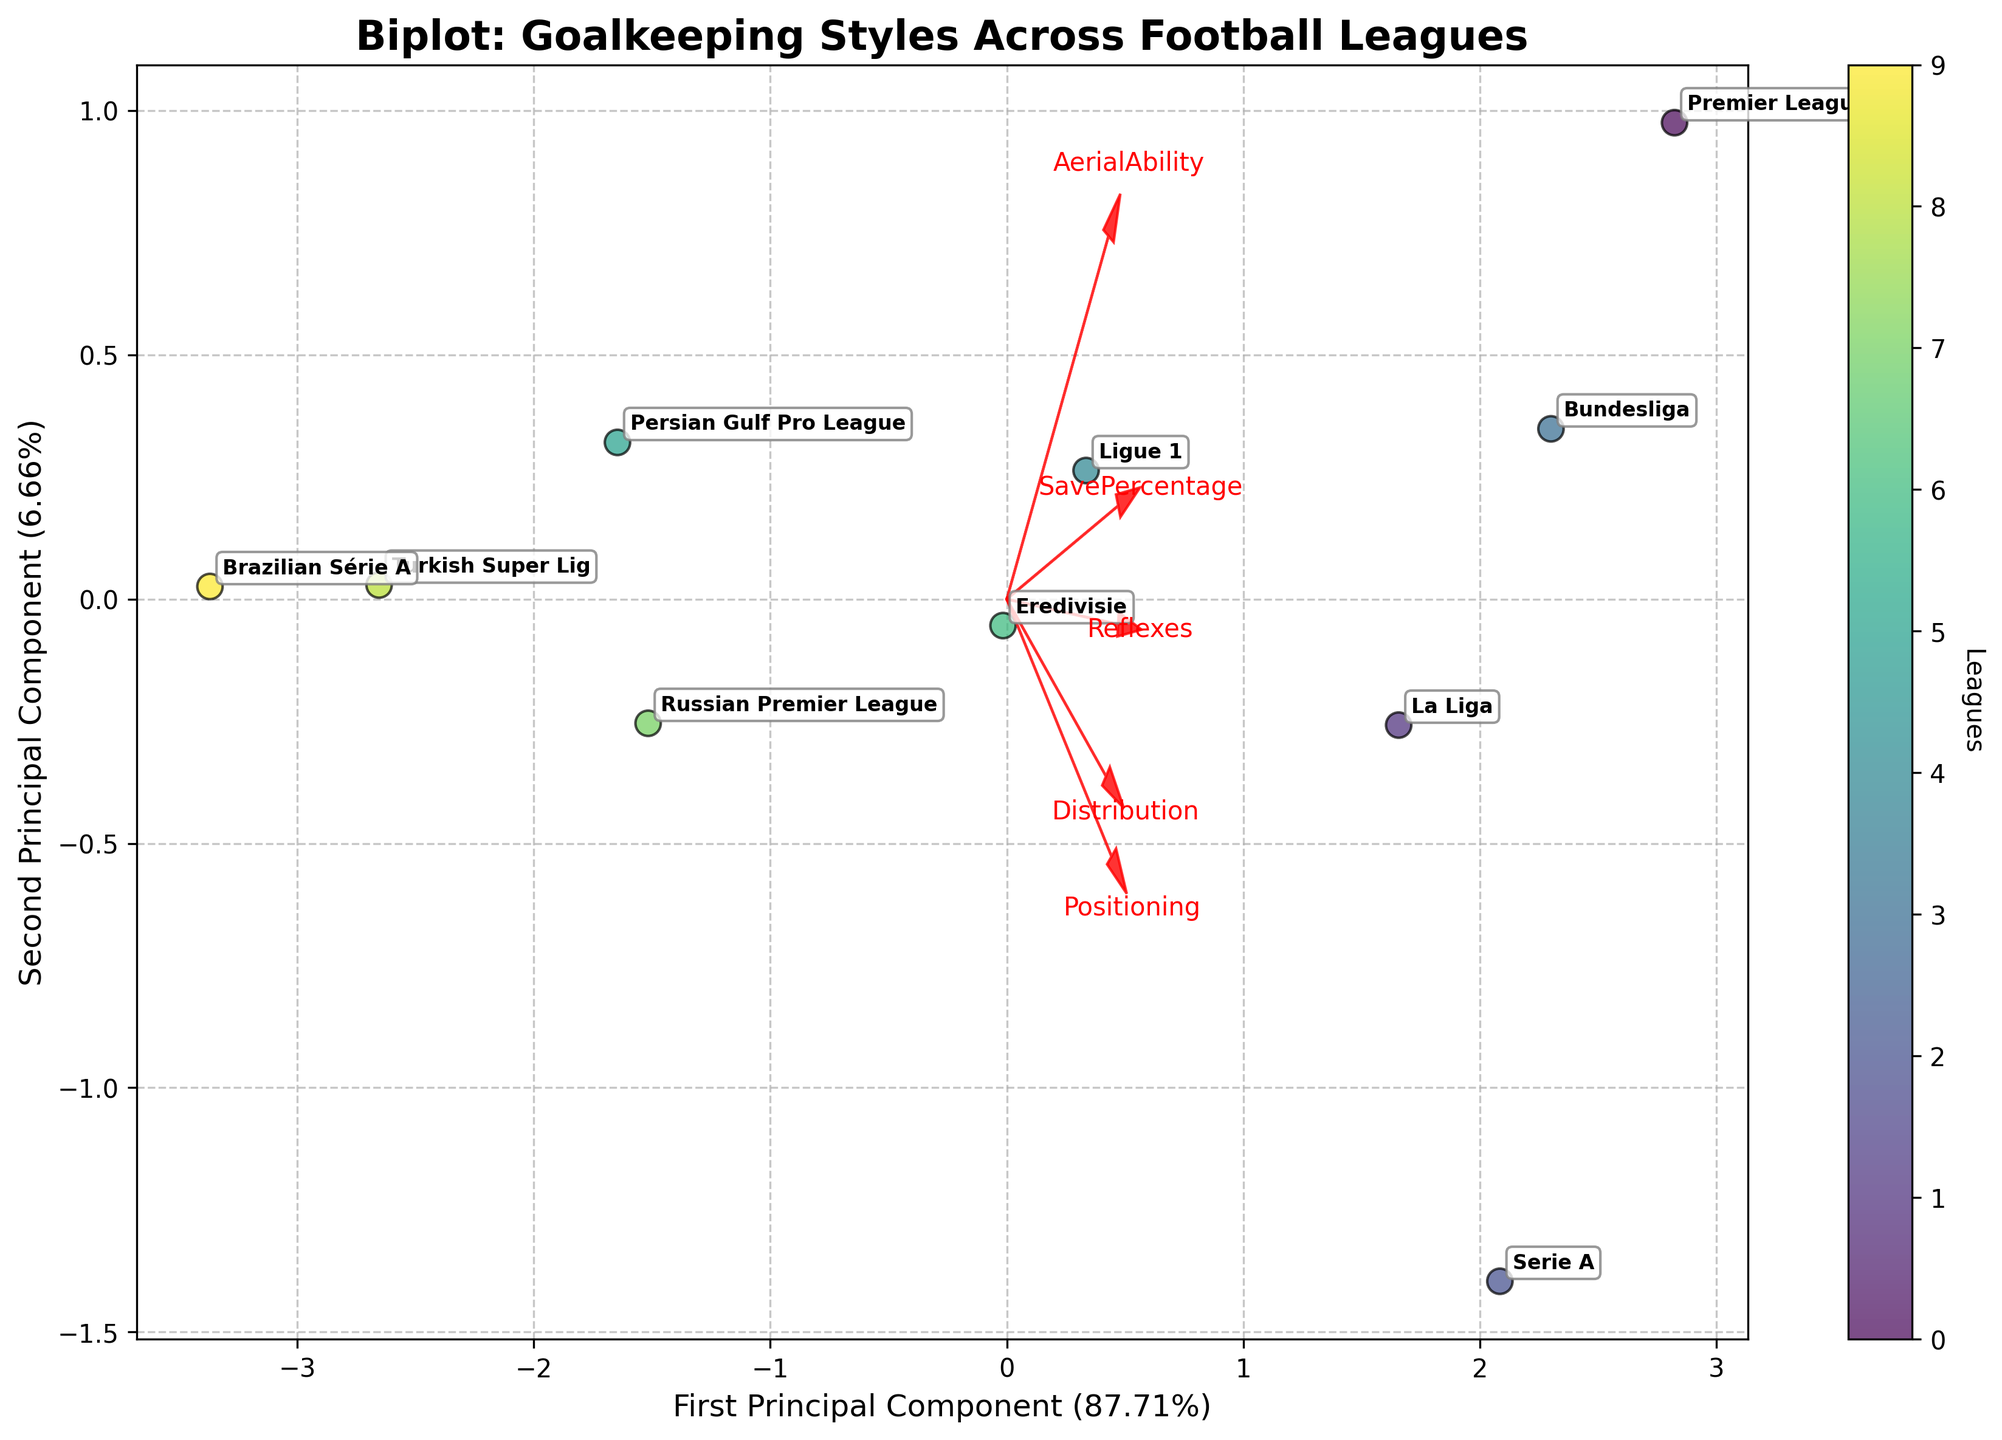What is the title of the plot? The title is typically located at the top of the plot and is often displayed in a larger or bold font. Here, the title reads "Biplot: Goalkeeping Styles Across Football Leagues".
Answer: Biplot: Goalkeeping Styles Across Football Leagues Which league has the highest Save Percentage? Review the distribution of the data points and their corresponding labels. The Premier League is indicated to have the highest Save Percentage value, as seen in the plot.
Answer: Premier League Which league has the lowest Positioning score? By examining the arrows representing the features, locate the positioning vector. Look for the data point furthest along the negative direction of this arrow, which, in this plot, is the Brazilian Série A.
Answer: Brazilian Série A How much of the variance is explained by the first Principal Component? The percentage of variance explained by each component is often labeled on the axis of the plot. Here, the x-axis label shows "First Principal Component (XX%)". We extract the percentage from this label.
Answer: (check axis label for the exact %) Which two leagues cluster closely together in the biplot? Identify clusters by looking for data points that are very close to each other. In this plot, the Bundesliga and La Liga can be seen clustering closely.
Answer: Bundesliga and La Liga How does the Persian Gulf Pro League's Distribution compare to the Premier League's Distribution? Follow the arrow representing the Distribution feature. The Premier League data point is further along in the positive direction relative to the Persian Gulf Pro League data point, indicating it has higher distribution.
Answer: Premier League has higher Distribution Which league shows a prominent balance of both Reflexes and Positioning? Locate the vectors for Reflexes and Positioning. The Serie A league lies well-balanced along these two vectors compared to others, suggesting balanced skills in both aspects.
Answer: Serie A What percentage of the variance is explained by the second Principal Component? This information is found in the y-axis label, where it states "Second Principal Component (YY%)". Extract the percentage from this label.
Answer: (check axis label for the exact %) Which feature appears to have the least variation across leagues based on the length of its vector? Shorter vectors indicate less influence and variation across the data. Here, the vector for 'Aerial Ability' appears shortest, suggesting the least variation.
Answer: Aerial Ability 